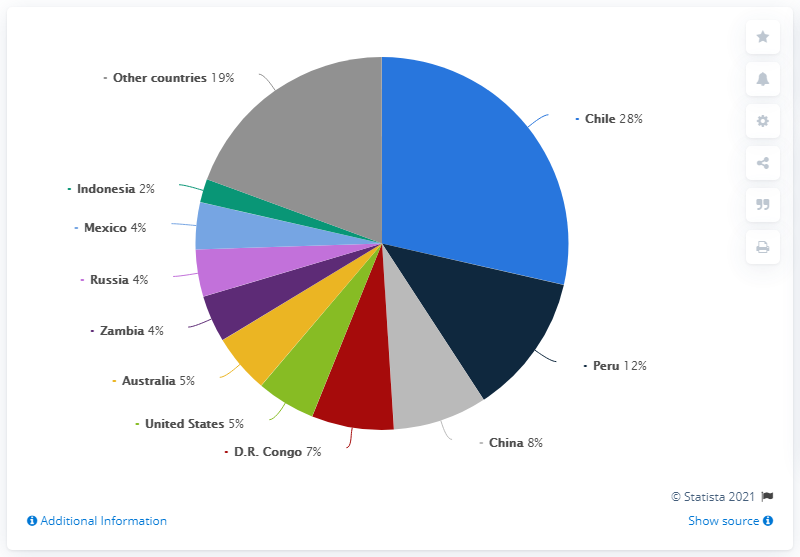Highlight a few significant elements in this photo. Chile was the world's largest producer of copper from mines in 2019. Chile was the country with the highest share in copper mine production in 2019. In 2019, the share of copper mine production from China and Peru accounted for approximately X% of the global production. 